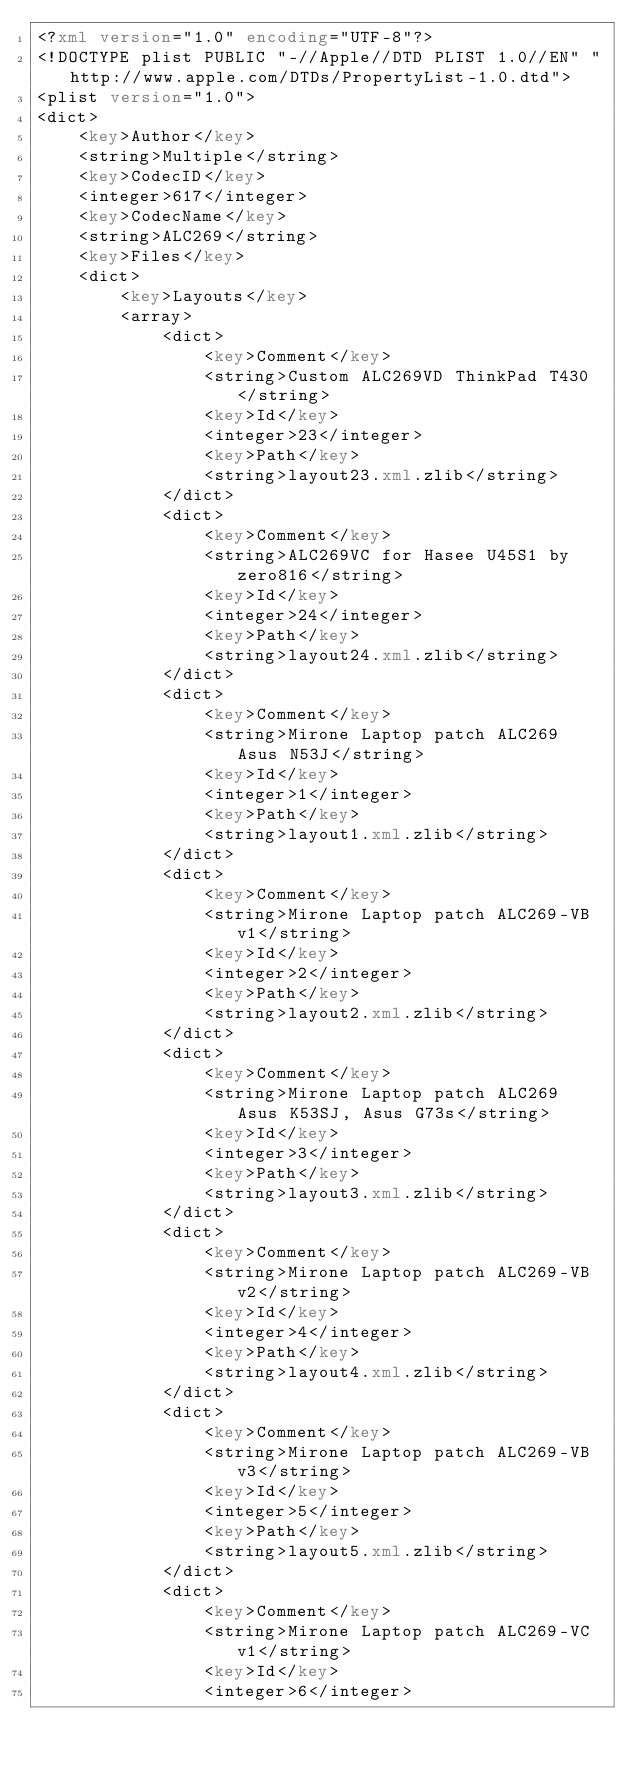Convert code to text. <code><loc_0><loc_0><loc_500><loc_500><_XML_><?xml version="1.0" encoding="UTF-8"?>
<!DOCTYPE plist PUBLIC "-//Apple//DTD PLIST 1.0//EN" "http://www.apple.com/DTDs/PropertyList-1.0.dtd">
<plist version="1.0">
<dict>
	<key>Author</key>
	<string>Multiple</string>
	<key>CodecID</key>
	<integer>617</integer>
	<key>CodecName</key>
	<string>ALC269</string>
	<key>Files</key>
	<dict>
		<key>Layouts</key>
		<array>
			<dict>
				<key>Comment</key>
				<string>Custom ALC269VD ThinkPad T430</string>
				<key>Id</key>
				<integer>23</integer>
				<key>Path</key>
				<string>layout23.xml.zlib</string>
			</dict>
			<dict>
				<key>Comment</key>
				<string>ALC269VC for Hasee U45S1 by zero816</string>
				<key>Id</key>
				<integer>24</integer>
				<key>Path</key>
				<string>layout24.xml.zlib</string>
			</dict>
			<dict>
				<key>Comment</key>
				<string>Mirone Laptop patch ALC269 Asus N53J</string>
				<key>Id</key>
				<integer>1</integer>
				<key>Path</key>
				<string>layout1.xml.zlib</string>
			</dict>
			<dict>
				<key>Comment</key>
				<string>Mirone Laptop patch ALC269-VB v1</string>
				<key>Id</key>
				<integer>2</integer>
				<key>Path</key>
				<string>layout2.xml.zlib</string>
			</dict>
			<dict>
				<key>Comment</key>
				<string>Mirone Laptop patch ALC269 Asus K53SJ, Asus G73s</string>
				<key>Id</key>
				<integer>3</integer>
				<key>Path</key>
				<string>layout3.xml.zlib</string>
			</dict>
			<dict>
				<key>Comment</key>
				<string>Mirone Laptop patch ALC269-VB v2</string>
				<key>Id</key>
				<integer>4</integer>
				<key>Path</key>
				<string>layout4.xml.zlib</string>
			</dict>
			<dict>
				<key>Comment</key>
				<string>Mirone Laptop patch ALC269-VB v3</string>
				<key>Id</key>
				<integer>5</integer>
				<key>Path</key>
				<string>layout5.xml.zlib</string>
			</dict>
			<dict>
				<key>Comment</key>
				<string>Mirone Laptop patch ALC269-VC v1</string>
				<key>Id</key>
				<integer>6</integer></code> 